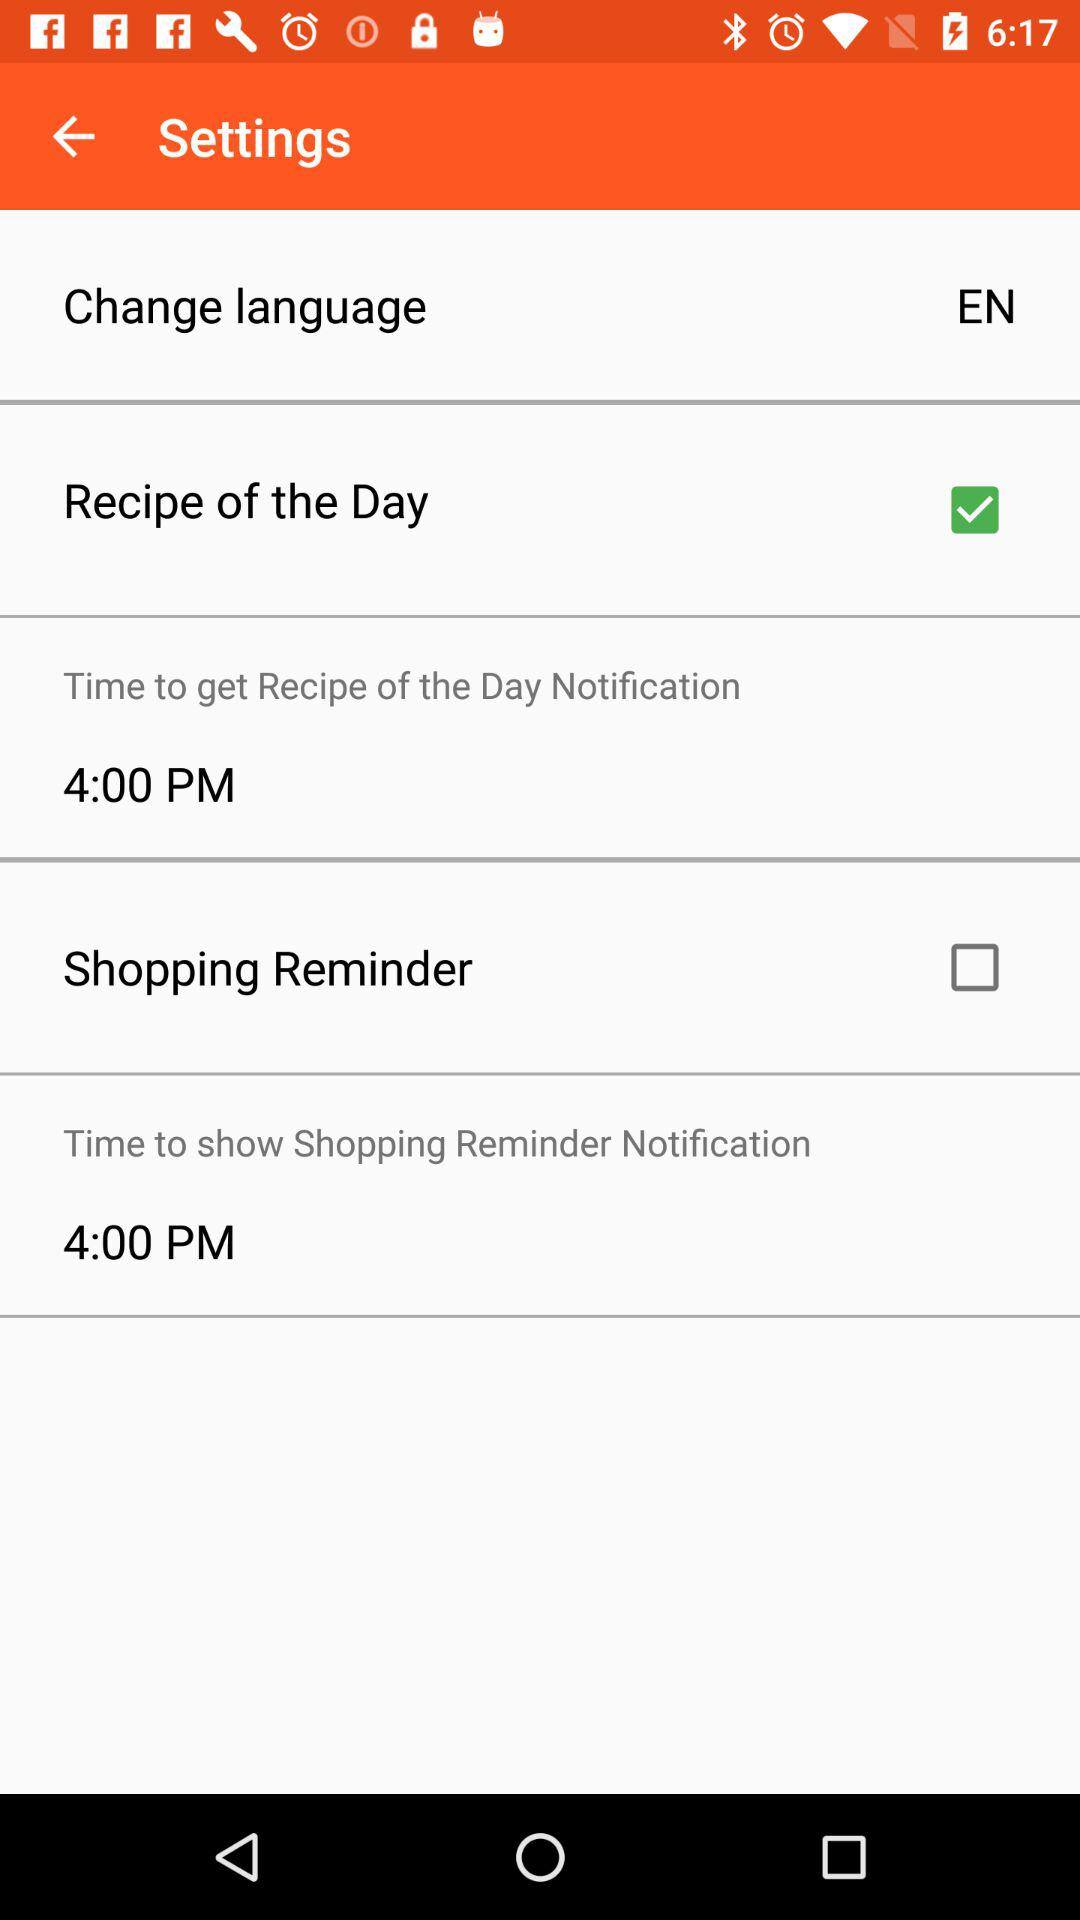What is the time to get the recipe of the day notification? The time is 4 PM. 